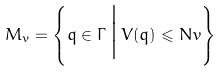Convert formula to latex. <formula><loc_0><loc_0><loc_500><loc_500>M _ { v } = \left \{ q \in \Gamma \, \Big | \, V ( q ) \leqslant N v \right \}</formula> 